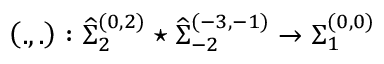<formula> <loc_0><loc_0><loc_500><loc_500>\left ( . , . \right ) \colon { \widehat { \Sigma } } _ { 2 } ^ { ( 0 , 2 ) } ^ { * } { \widehat { \Sigma } } _ { - 2 } ^ { ( - 3 , - 1 ) } \rightarrow { \Sigma } _ { 1 } ^ { ( 0 , 0 ) }</formula> 